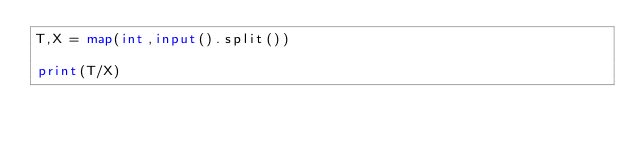<code> <loc_0><loc_0><loc_500><loc_500><_Python_>T,X = map(int,input().split())

print(T/X)
</code> 